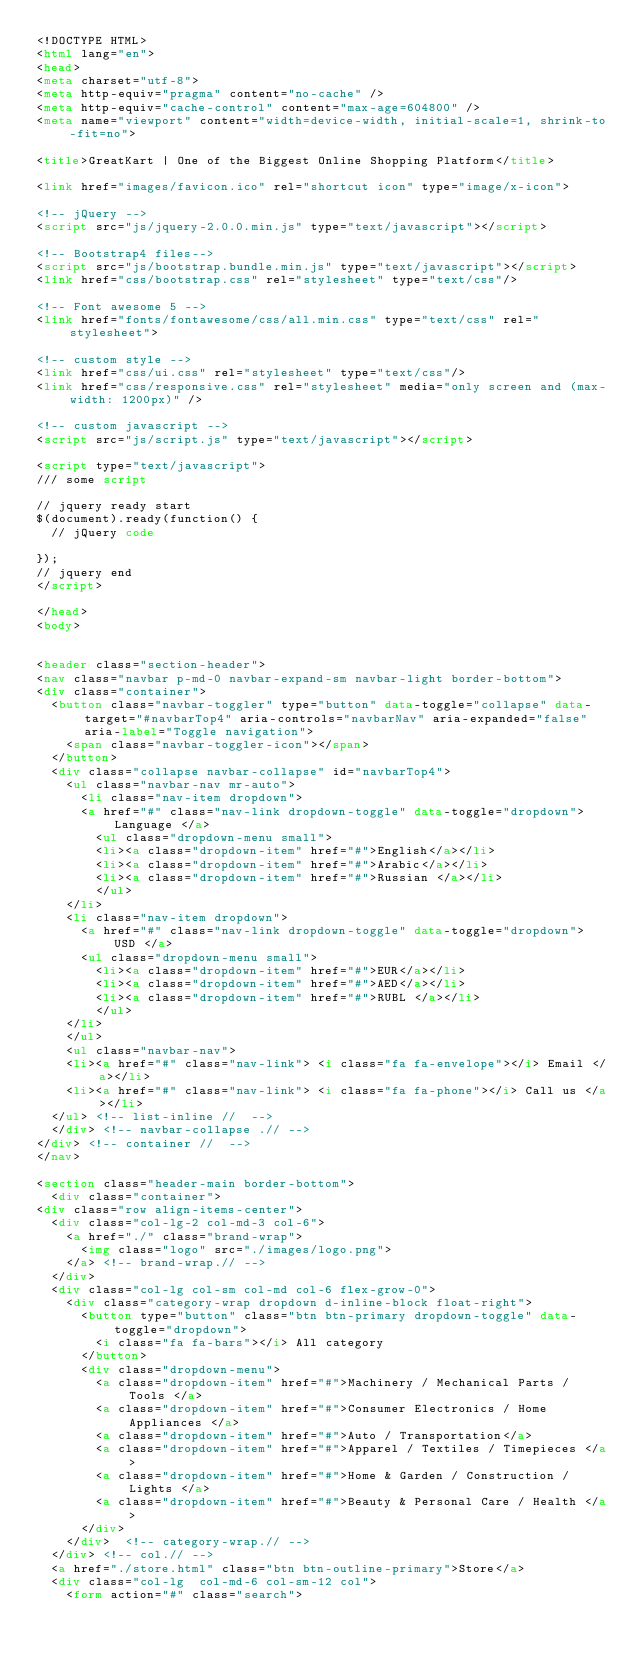Convert code to text. <code><loc_0><loc_0><loc_500><loc_500><_HTML_><!DOCTYPE HTML>
<html lang="en">
<head>
<meta charset="utf-8">
<meta http-equiv="pragma" content="no-cache" />
<meta http-equiv="cache-control" content="max-age=604800" />
<meta name="viewport" content="width=device-width, initial-scale=1, shrink-to-fit=no">

<title>GreatKart | One of the Biggest Online Shopping Platform</title>

<link href="images/favicon.ico" rel="shortcut icon" type="image/x-icon">

<!-- jQuery -->
<script src="js/jquery-2.0.0.min.js" type="text/javascript"></script>

<!-- Bootstrap4 files-->
<script src="js/bootstrap.bundle.min.js" type="text/javascript"></script>
<link href="css/bootstrap.css" rel="stylesheet" type="text/css"/>

<!-- Font awesome 5 -->
<link href="fonts/fontawesome/css/all.min.css" type="text/css" rel="stylesheet">

<!-- custom style -->
<link href="css/ui.css" rel="stylesheet" type="text/css"/>
<link href="css/responsive.css" rel="stylesheet" media="only screen and (max-width: 1200px)" />

<!-- custom javascript -->
<script src="js/script.js" type="text/javascript"></script>

<script type="text/javascript">
/// some script

// jquery ready start
$(document).ready(function() {
	// jQuery code

}); 
// jquery end
</script>

</head>
<body>


<header class="section-header">
<nav class="navbar p-md-0 navbar-expand-sm navbar-light border-bottom">
<div class="container">
  <button class="navbar-toggler" type="button" data-toggle="collapse" data-target="#navbarTop4" aria-controls="navbarNav" aria-expanded="false" aria-label="Toggle navigation">
    <span class="navbar-toggler-icon"></span>
  </button>
  <div class="collapse navbar-collapse" id="navbarTop4">
    <ul class="navbar-nav mr-auto">
    	<li class="nav-item dropdown">
		 	<a href="#" class="nav-link dropdown-toggle" data-toggle="dropdown">   Language </a>
		    <ul class="dropdown-menu small">
				<li><a class="dropdown-item" href="#">English</a></li>
				<li><a class="dropdown-item" href="#">Arabic</a></li>
				<li><a class="dropdown-item" href="#">Russian </a></li>
		    </ul>
		</li>
		<li class="nav-item dropdown">
			<a href="#" class="nav-link dropdown-toggle" data-toggle="dropdown"> USD </a>
			<ul class="dropdown-menu small">
				<li><a class="dropdown-item" href="#">EUR</a></li>
				<li><a class="dropdown-item" href="#">AED</a></li>
				<li><a class="dropdown-item" href="#">RUBL </a></li>
		    </ul>
		</li>
    </ul>
    <ul class="navbar-nav">
		<li><a href="#" class="nav-link"> <i class="fa fa-envelope"></i> Email </a></li>
		<li><a href="#" class="nav-link"> <i class="fa fa-phone"></i> Call us </a></li>
	</ul> <!-- list-inline //  -->
  </div> <!-- navbar-collapse .// -->
</div> <!-- container //  -->
</nav>

<section class="header-main border-bottom">
	<div class="container">
<div class="row align-items-center">
	<div class="col-lg-2 col-md-3 col-6">
		<a href="./" class="brand-wrap">
			<img class="logo" src="./images/logo.png">
		</a> <!-- brand-wrap.// -->
	</div>
	<div class="col-lg col-sm col-md col-6 flex-grow-0">
		<div class="category-wrap dropdown d-inline-block float-right">
			<button type="button" class="btn btn-primary dropdown-toggle" data-toggle="dropdown"> 
				<i class="fa fa-bars"></i> All category 
			</button>
			<div class="dropdown-menu">
				<a class="dropdown-item" href="#">Machinery / Mechanical Parts / Tools </a>
				<a class="dropdown-item" href="#">Consumer Electronics / Home Appliances </a>
				<a class="dropdown-item" href="#">Auto / Transportation</a>
				<a class="dropdown-item" href="#">Apparel / Textiles / Timepieces </a>
				<a class="dropdown-item" href="#">Home & Garden / Construction / Lights </a>
				<a class="dropdown-item" href="#">Beauty & Personal Care / Health </a> 
			</div>
		</div>  <!-- category-wrap.// -->
	</div> <!-- col.// -->
	<a href="./store.html" class="btn btn-outline-primary">Store</a>
	<div class="col-lg  col-md-6 col-sm-12 col">
		<form action="#" class="search"></code> 